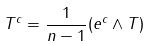Convert formula to latex. <formula><loc_0><loc_0><loc_500><loc_500>T ^ { c } = \frac { 1 } { n - 1 } ( e ^ { c } \wedge T )</formula> 